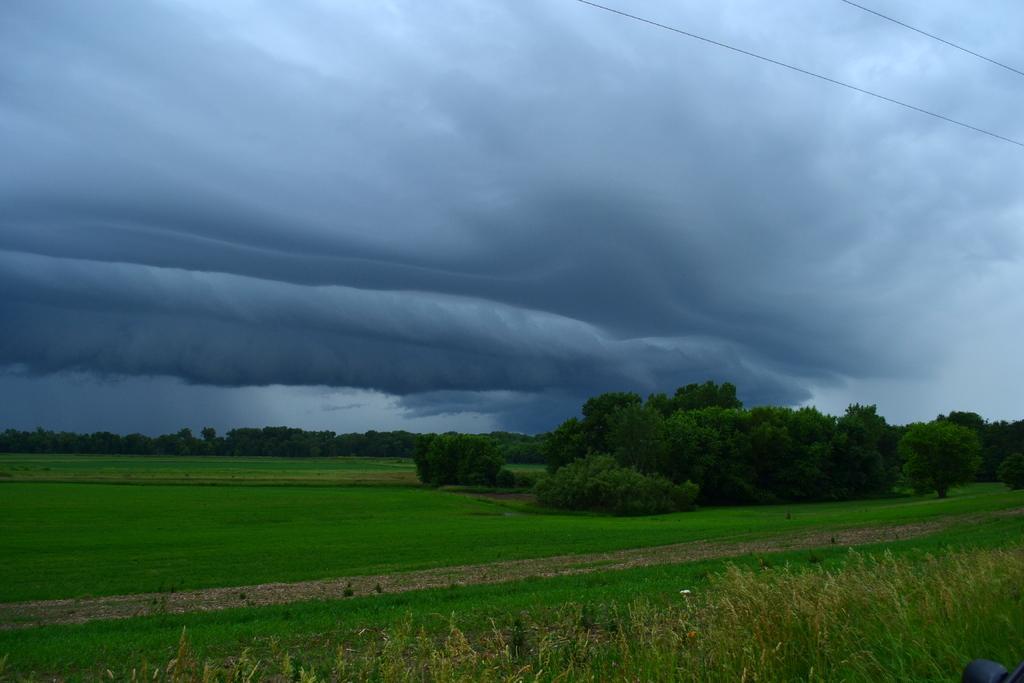How would you summarize this image in a sentence or two? In this image, there are trees, grass and plants. In the top right corner of the image, I can see the current wires. In the background, there is the sky. 